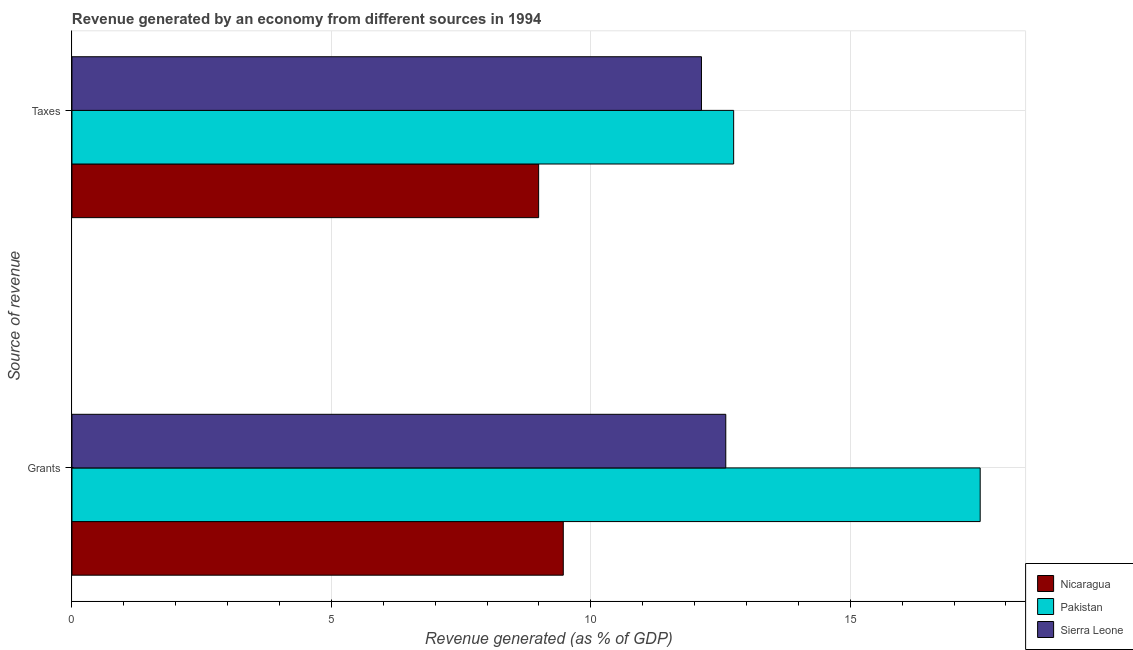How many different coloured bars are there?
Offer a very short reply. 3. How many groups of bars are there?
Make the answer very short. 2. Are the number of bars per tick equal to the number of legend labels?
Provide a short and direct response. Yes. Are the number of bars on each tick of the Y-axis equal?
Ensure brevity in your answer.  Yes. How many bars are there on the 1st tick from the top?
Your answer should be compact. 3. How many bars are there on the 2nd tick from the bottom?
Your answer should be very brief. 3. What is the label of the 2nd group of bars from the top?
Your response must be concise. Grants. What is the revenue generated by grants in Pakistan?
Provide a succinct answer. 17.5. Across all countries, what is the maximum revenue generated by grants?
Offer a terse response. 17.5. Across all countries, what is the minimum revenue generated by taxes?
Your answer should be compact. 8.99. In which country was the revenue generated by grants minimum?
Your answer should be very brief. Nicaragua. What is the total revenue generated by taxes in the graph?
Provide a short and direct response. 33.88. What is the difference between the revenue generated by taxes in Sierra Leone and that in Nicaragua?
Make the answer very short. 3.14. What is the difference between the revenue generated by grants in Nicaragua and the revenue generated by taxes in Pakistan?
Provide a succinct answer. -3.28. What is the average revenue generated by taxes per country?
Provide a succinct answer. 11.29. What is the difference between the revenue generated by grants and revenue generated by taxes in Pakistan?
Your answer should be compact. 4.75. In how many countries, is the revenue generated by grants greater than 4 %?
Keep it short and to the point. 3. What is the ratio of the revenue generated by grants in Nicaragua to that in Sierra Leone?
Your response must be concise. 0.75. What does the 1st bar from the top in Grants represents?
Provide a short and direct response. Sierra Leone. What does the 1st bar from the bottom in Grants represents?
Your answer should be very brief. Nicaragua. How many bars are there?
Make the answer very short. 6. How many countries are there in the graph?
Make the answer very short. 3. Are the values on the major ticks of X-axis written in scientific E-notation?
Offer a terse response. No. Does the graph contain grids?
Keep it short and to the point. Yes. How many legend labels are there?
Offer a terse response. 3. What is the title of the graph?
Offer a terse response. Revenue generated by an economy from different sources in 1994. What is the label or title of the X-axis?
Offer a terse response. Revenue generated (as % of GDP). What is the label or title of the Y-axis?
Your response must be concise. Source of revenue. What is the Revenue generated (as % of GDP) of Nicaragua in Grants?
Offer a very short reply. 9.47. What is the Revenue generated (as % of GDP) in Pakistan in Grants?
Keep it short and to the point. 17.5. What is the Revenue generated (as % of GDP) in Sierra Leone in Grants?
Offer a terse response. 12.6. What is the Revenue generated (as % of GDP) of Nicaragua in Taxes?
Your answer should be very brief. 8.99. What is the Revenue generated (as % of GDP) in Pakistan in Taxes?
Provide a short and direct response. 12.75. What is the Revenue generated (as % of GDP) in Sierra Leone in Taxes?
Keep it short and to the point. 12.13. Across all Source of revenue, what is the maximum Revenue generated (as % of GDP) of Nicaragua?
Keep it short and to the point. 9.47. Across all Source of revenue, what is the maximum Revenue generated (as % of GDP) of Pakistan?
Give a very brief answer. 17.5. Across all Source of revenue, what is the maximum Revenue generated (as % of GDP) of Sierra Leone?
Keep it short and to the point. 12.6. Across all Source of revenue, what is the minimum Revenue generated (as % of GDP) of Nicaragua?
Keep it short and to the point. 8.99. Across all Source of revenue, what is the minimum Revenue generated (as % of GDP) in Pakistan?
Your answer should be compact. 12.75. Across all Source of revenue, what is the minimum Revenue generated (as % of GDP) in Sierra Leone?
Make the answer very short. 12.13. What is the total Revenue generated (as % of GDP) of Nicaragua in the graph?
Offer a very short reply. 18.46. What is the total Revenue generated (as % of GDP) in Pakistan in the graph?
Your answer should be compact. 30.25. What is the total Revenue generated (as % of GDP) in Sierra Leone in the graph?
Your response must be concise. 24.73. What is the difference between the Revenue generated (as % of GDP) of Nicaragua in Grants and that in Taxes?
Offer a terse response. 0.47. What is the difference between the Revenue generated (as % of GDP) of Pakistan in Grants and that in Taxes?
Provide a short and direct response. 4.75. What is the difference between the Revenue generated (as % of GDP) in Sierra Leone in Grants and that in Taxes?
Make the answer very short. 0.47. What is the difference between the Revenue generated (as % of GDP) of Nicaragua in Grants and the Revenue generated (as % of GDP) of Pakistan in Taxes?
Keep it short and to the point. -3.28. What is the difference between the Revenue generated (as % of GDP) of Nicaragua in Grants and the Revenue generated (as % of GDP) of Sierra Leone in Taxes?
Keep it short and to the point. -2.66. What is the difference between the Revenue generated (as % of GDP) in Pakistan in Grants and the Revenue generated (as % of GDP) in Sierra Leone in Taxes?
Ensure brevity in your answer.  5.37. What is the average Revenue generated (as % of GDP) of Nicaragua per Source of revenue?
Your response must be concise. 9.23. What is the average Revenue generated (as % of GDP) in Pakistan per Source of revenue?
Make the answer very short. 15.13. What is the average Revenue generated (as % of GDP) of Sierra Leone per Source of revenue?
Provide a succinct answer. 12.37. What is the difference between the Revenue generated (as % of GDP) of Nicaragua and Revenue generated (as % of GDP) of Pakistan in Grants?
Your answer should be very brief. -8.03. What is the difference between the Revenue generated (as % of GDP) of Nicaragua and Revenue generated (as % of GDP) of Sierra Leone in Grants?
Make the answer very short. -3.13. What is the difference between the Revenue generated (as % of GDP) of Pakistan and Revenue generated (as % of GDP) of Sierra Leone in Grants?
Your answer should be very brief. 4.9. What is the difference between the Revenue generated (as % of GDP) of Nicaragua and Revenue generated (as % of GDP) of Pakistan in Taxes?
Provide a succinct answer. -3.76. What is the difference between the Revenue generated (as % of GDP) of Nicaragua and Revenue generated (as % of GDP) of Sierra Leone in Taxes?
Provide a succinct answer. -3.14. What is the difference between the Revenue generated (as % of GDP) of Pakistan and Revenue generated (as % of GDP) of Sierra Leone in Taxes?
Your answer should be compact. 0.62. What is the ratio of the Revenue generated (as % of GDP) of Nicaragua in Grants to that in Taxes?
Keep it short and to the point. 1.05. What is the ratio of the Revenue generated (as % of GDP) in Pakistan in Grants to that in Taxes?
Offer a terse response. 1.37. What is the ratio of the Revenue generated (as % of GDP) of Sierra Leone in Grants to that in Taxes?
Offer a terse response. 1.04. What is the difference between the highest and the second highest Revenue generated (as % of GDP) in Nicaragua?
Provide a short and direct response. 0.47. What is the difference between the highest and the second highest Revenue generated (as % of GDP) of Pakistan?
Provide a short and direct response. 4.75. What is the difference between the highest and the second highest Revenue generated (as % of GDP) in Sierra Leone?
Give a very brief answer. 0.47. What is the difference between the highest and the lowest Revenue generated (as % of GDP) of Nicaragua?
Offer a terse response. 0.47. What is the difference between the highest and the lowest Revenue generated (as % of GDP) in Pakistan?
Give a very brief answer. 4.75. What is the difference between the highest and the lowest Revenue generated (as % of GDP) of Sierra Leone?
Your answer should be compact. 0.47. 